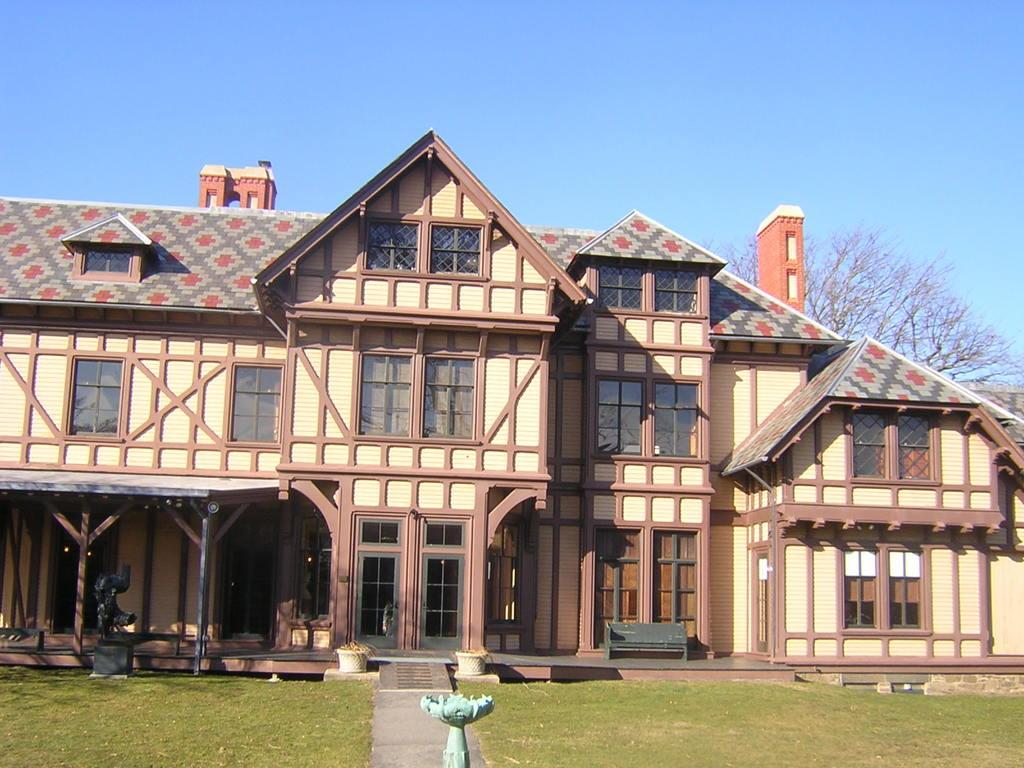What type of ground cover is visible in the image? There is green grass on the ground in the image. What type of structure is present in the image? There is a building in the image. Where is the tree located in the image? There is a tree in the background on the right side of the image. What color is the sky in the image? The sky is blue and visible at the top of the image. What sense is being used by the toad in the image? There is no toad present in the image, so it is not possible to determine which sense is being used. 